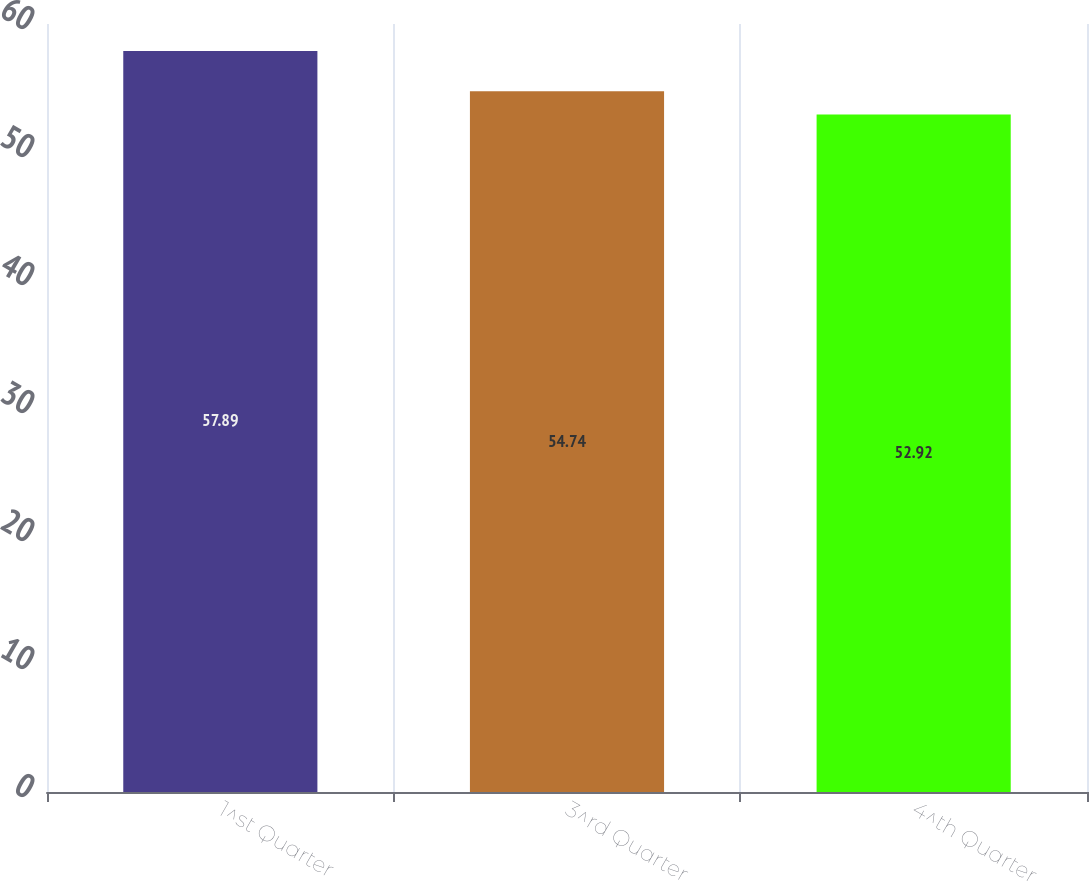<chart> <loc_0><loc_0><loc_500><loc_500><bar_chart><fcel>1^st Quarter<fcel>3^rd Quarter<fcel>4^th Quarter<nl><fcel>57.89<fcel>54.74<fcel>52.92<nl></chart> 